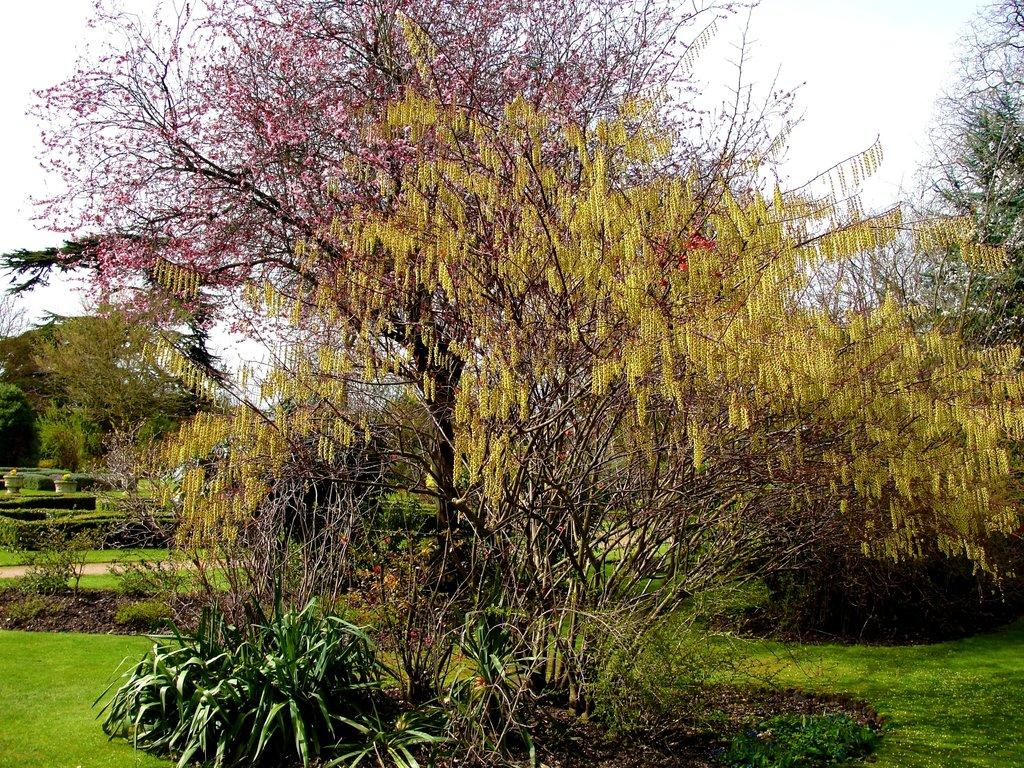What type of vegetation can be seen in the image? There are trees, plants, and grass visible in the image. What part of the natural environment is visible in the image? The sky is visible in the background of the image. What type of cord is being used to hang the tent in the image? There is no tent present in the image, so it is not possible to determine what type of cord might be used. 